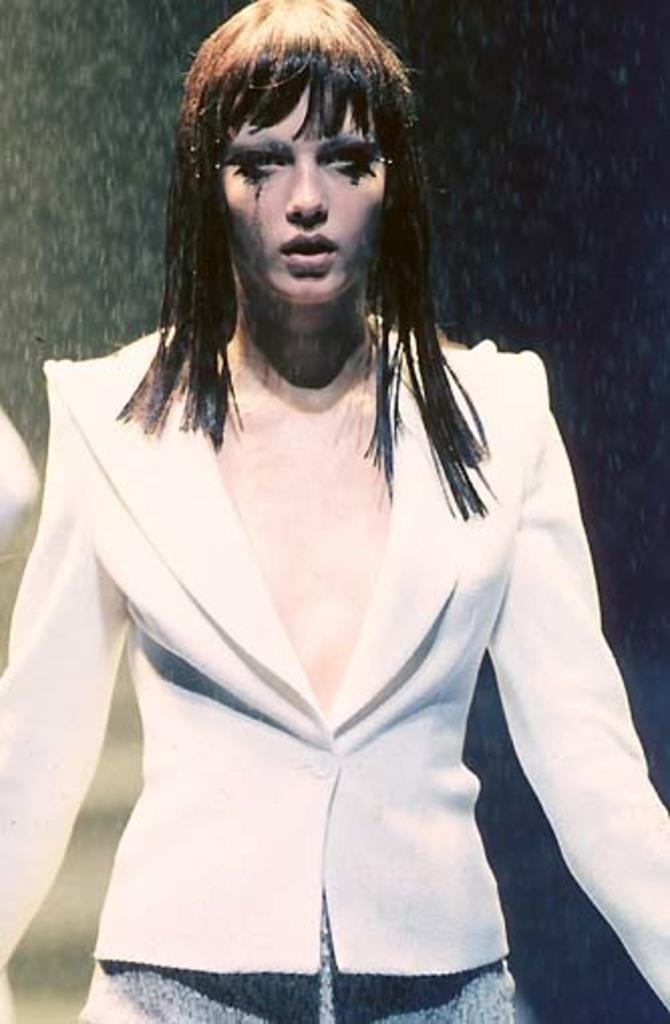Who is present in the image? There is a woman in the image. What is the woman doing in the image? The woman is standing. What is the woman wearing in the image? The woman is wearing a white coat. What is the committee discussing in the image? There is no committee present in the image, and therefore no discussion can be observed. What is on the back of the woman in the image? The provided facts do not mention anything about the back of the woman, so we cannot answer this question definitively. 